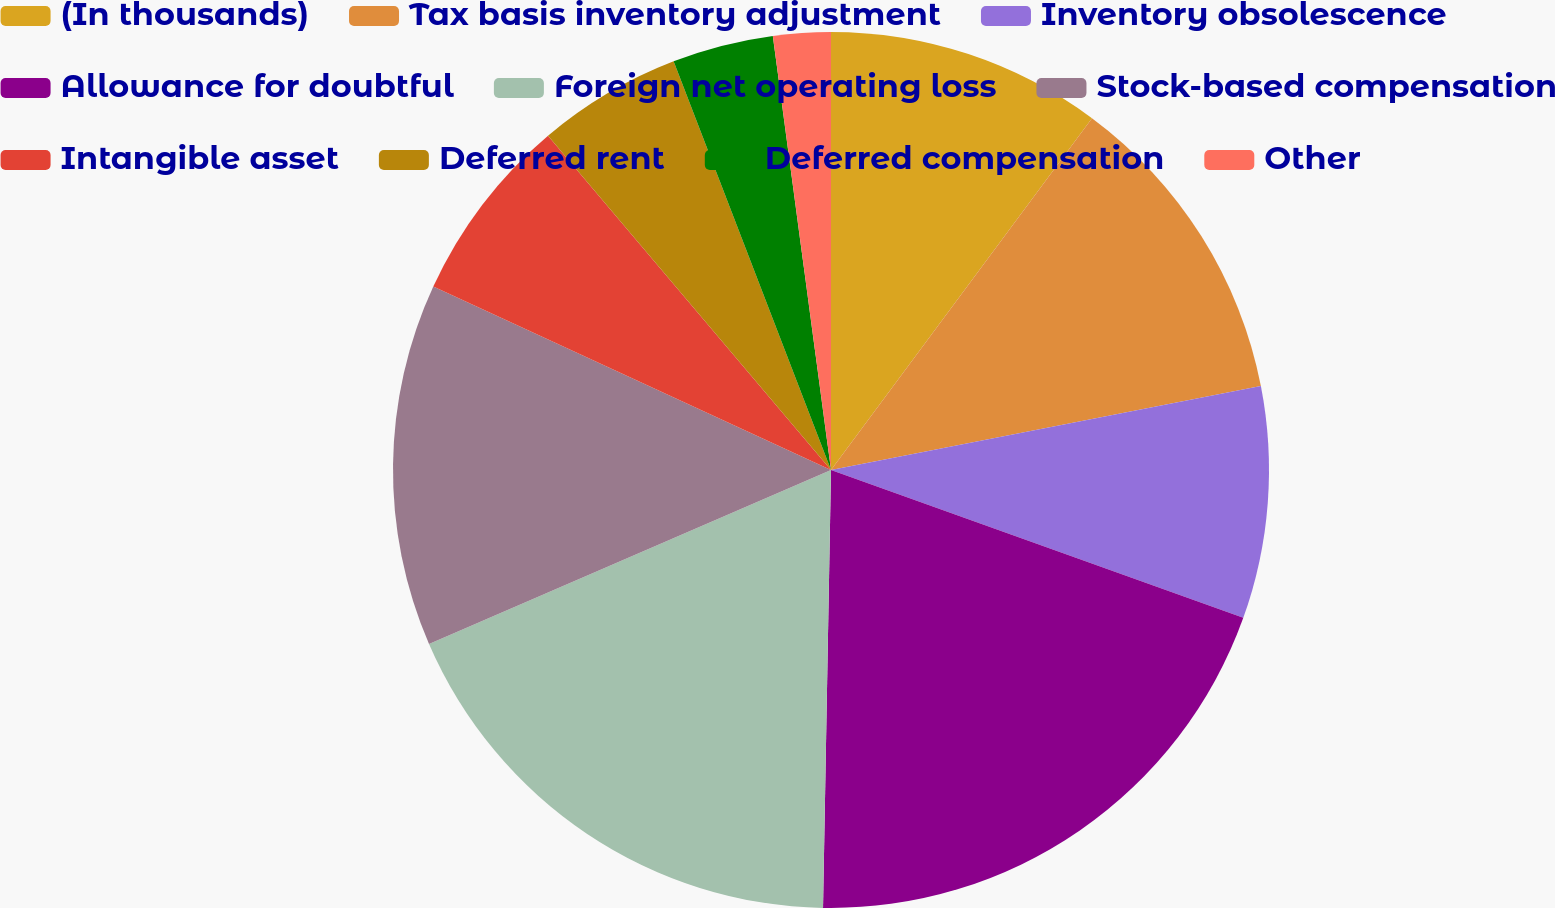<chart> <loc_0><loc_0><loc_500><loc_500><pie_chart><fcel>(In thousands)<fcel>Tax basis inventory adjustment<fcel>Inventory obsolescence<fcel>Allowance for doubtful<fcel>Foreign net operating loss<fcel>Stock-based compensation<fcel>Intangible asset<fcel>Deferred rent<fcel>Deferred compensation<fcel>Other<nl><fcel>10.16%<fcel>11.77%<fcel>8.55%<fcel>19.81%<fcel>18.21%<fcel>13.38%<fcel>6.94%<fcel>5.33%<fcel>3.73%<fcel>2.12%<nl></chart> 